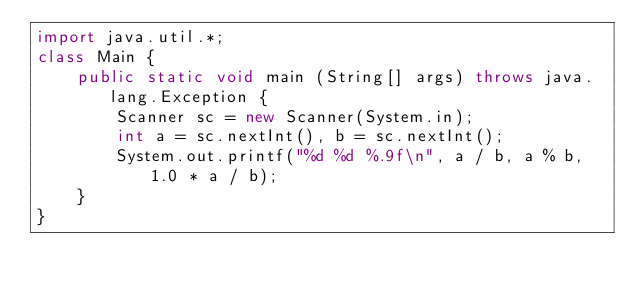Convert code to text. <code><loc_0><loc_0><loc_500><loc_500><_Java_>import java.util.*;
class Main {
	public static void main (String[] args) throws java.lang.Exception {
		Scanner sc = new Scanner(System.in);
		int a = sc.nextInt(), b = sc.nextInt();
		System.out.printf("%d %d %.9f\n", a / b, a % b, 1.0 * a / b);
	}
}</code> 